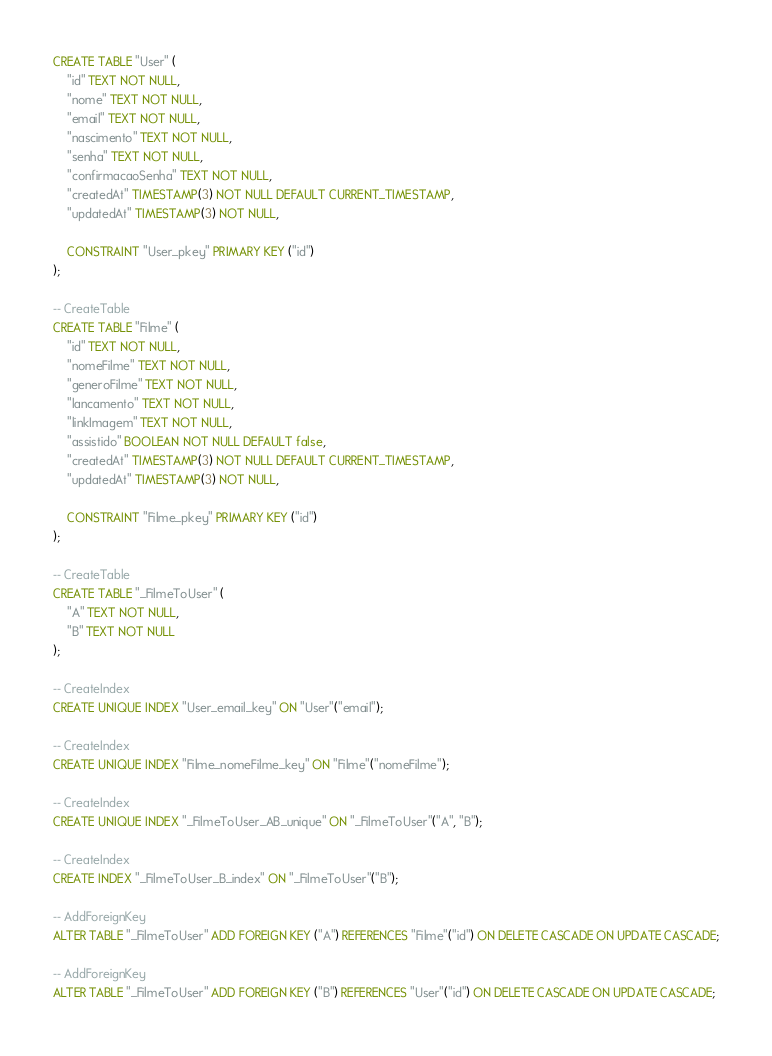Convert code to text. <code><loc_0><loc_0><loc_500><loc_500><_SQL_>CREATE TABLE "User" (
    "id" TEXT NOT NULL,
    "nome" TEXT NOT NULL,
    "email" TEXT NOT NULL,
    "nascimento" TEXT NOT NULL,
    "senha" TEXT NOT NULL,
    "confirmacaoSenha" TEXT NOT NULL,
    "createdAt" TIMESTAMP(3) NOT NULL DEFAULT CURRENT_TIMESTAMP,
    "updatedAt" TIMESTAMP(3) NOT NULL,

    CONSTRAINT "User_pkey" PRIMARY KEY ("id")
);

-- CreateTable
CREATE TABLE "Filme" (
    "id" TEXT NOT NULL,
    "nomeFilme" TEXT NOT NULL,
    "generoFilme" TEXT NOT NULL,
    "lancamento" TEXT NOT NULL,
    "linkImagem" TEXT NOT NULL,
    "assistido" BOOLEAN NOT NULL DEFAULT false,
    "createdAt" TIMESTAMP(3) NOT NULL DEFAULT CURRENT_TIMESTAMP,
    "updatedAt" TIMESTAMP(3) NOT NULL,

    CONSTRAINT "Filme_pkey" PRIMARY KEY ("id")
);

-- CreateTable
CREATE TABLE "_FilmeToUser" (
    "A" TEXT NOT NULL,
    "B" TEXT NOT NULL
);

-- CreateIndex
CREATE UNIQUE INDEX "User_email_key" ON "User"("email");

-- CreateIndex
CREATE UNIQUE INDEX "Filme_nomeFilme_key" ON "Filme"("nomeFilme");

-- CreateIndex
CREATE UNIQUE INDEX "_FilmeToUser_AB_unique" ON "_FilmeToUser"("A", "B");

-- CreateIndex
CREATE INDEX "_FilmeToUser_B_index" ON "_FilmeToUser"("B");

-- AddForeignKey
ALTER TABLE "_FilmeToUser" ADD FOREIGN KEY ("A") REFERENCES "Filme"("id") ON DELETE CASCADE ON UPDATE CASCADE;

-- AddForeignKey
ALTER TABLE "_FilmeToUser" ADD FOREIGN KEY ("B") REFERENCES "User"("id") ON DELETE CASCADE ON UPDATE CASCADE;
</code> 